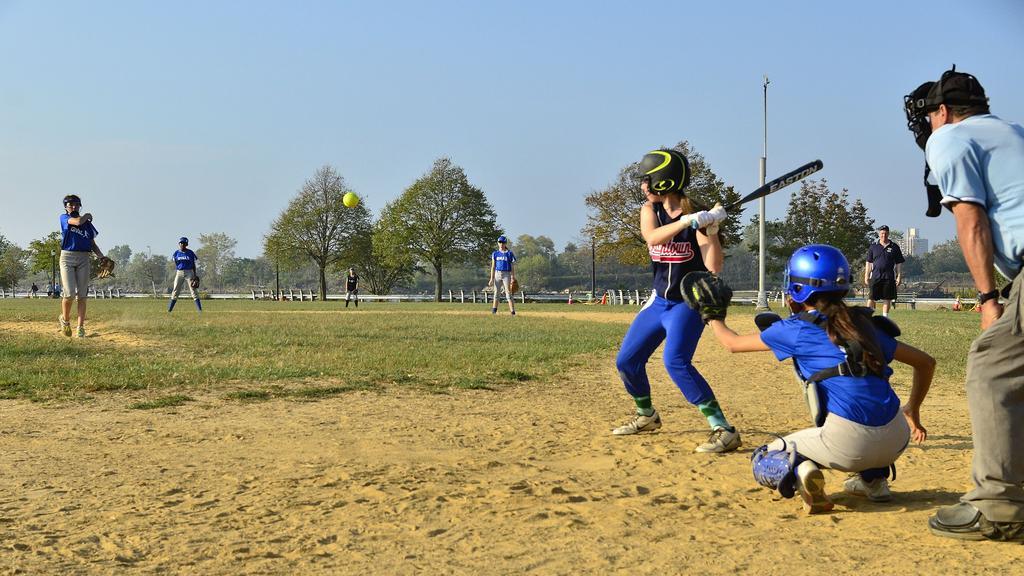Could you give a brief overview of what you see in this image? In this image there is a ground in the bottom of this image. There is one person standing on the right side of this image is holding a bat and there is one other person is sitting on the right side to this person and wearing black color dress and blue color helmet and there is one other person is at right side of this image. There is one person standing in middle of this image and there are some persons are on the left side of this image. There are some trees in the background. There is a sky at top on the top of this image. 